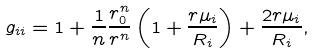Convert formula to latex. <formula><loc_0><loc_0><loc_500><loc_500>g _ { i i } = 1 + \frac { 1 } { n } \frac { r _ { 0 } ^ { n } } { r ^ { n } } \left ( 1 + \frac { r \mu _ { i } } { R _ { i } } \right ) + \frac { 2 r \mu _ { i } } { R _ { i } } ,</formula> 